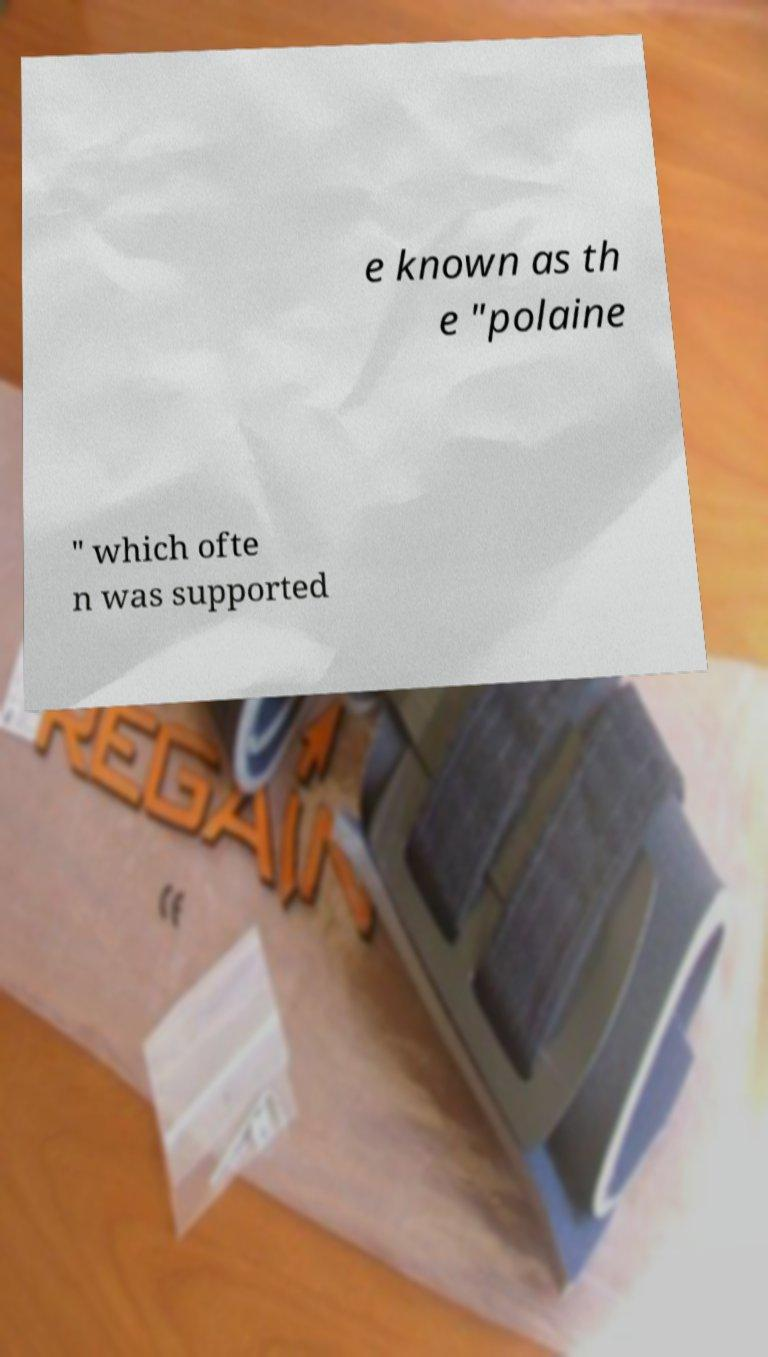I need the written content from this picture converted into text. Can you do that? e known as th e "polaine " which ofte n was supported 